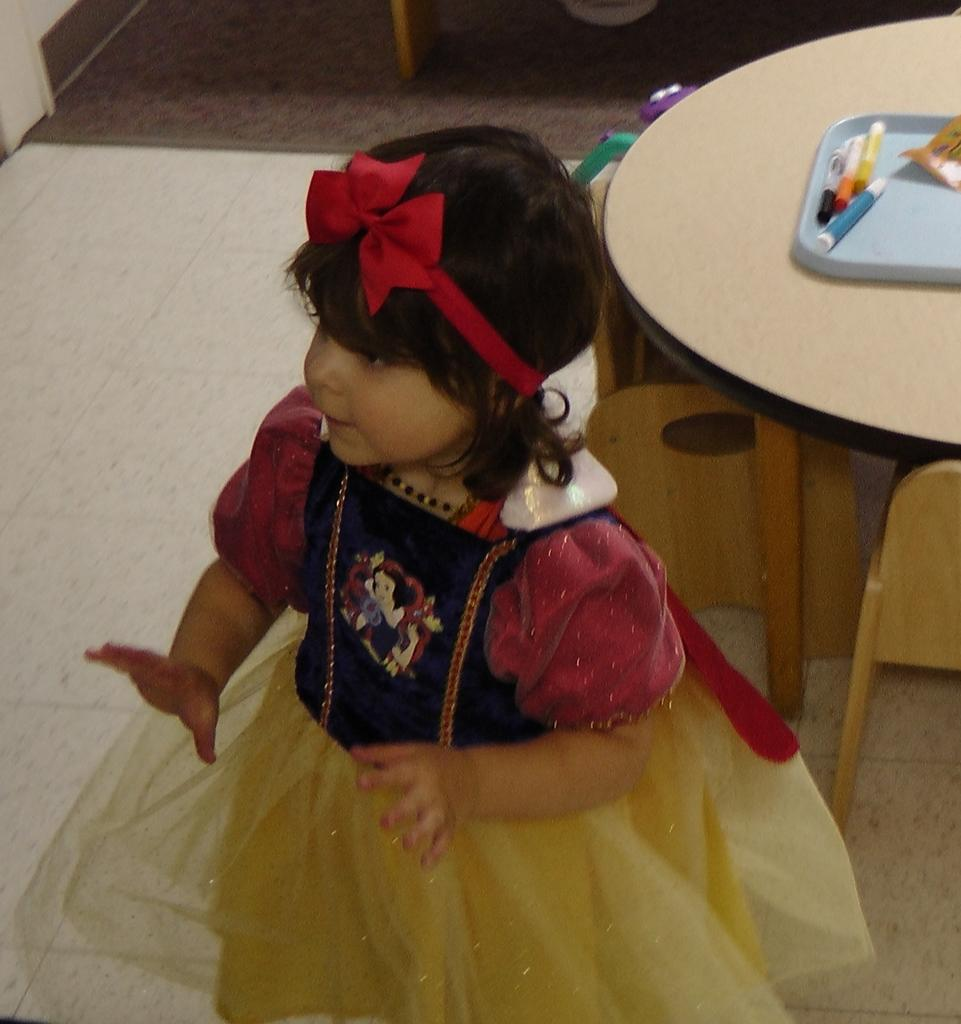Who is the main subject in the image? There is a girl in the image. What is the girl wearing? The girl is wearing a gown. What is the girl's position in the image? The girl is standing on the floor. What accessory is the girl wearing on her head? The girl is wearing a red color headband. What can be seen in the background of the image? There is a table in the background of the image. What is on the table in the image? There are accessories on the table. What type of bell can be heard ringing in the image? There is no bell present in the image, and therefore no sound can be heard. 